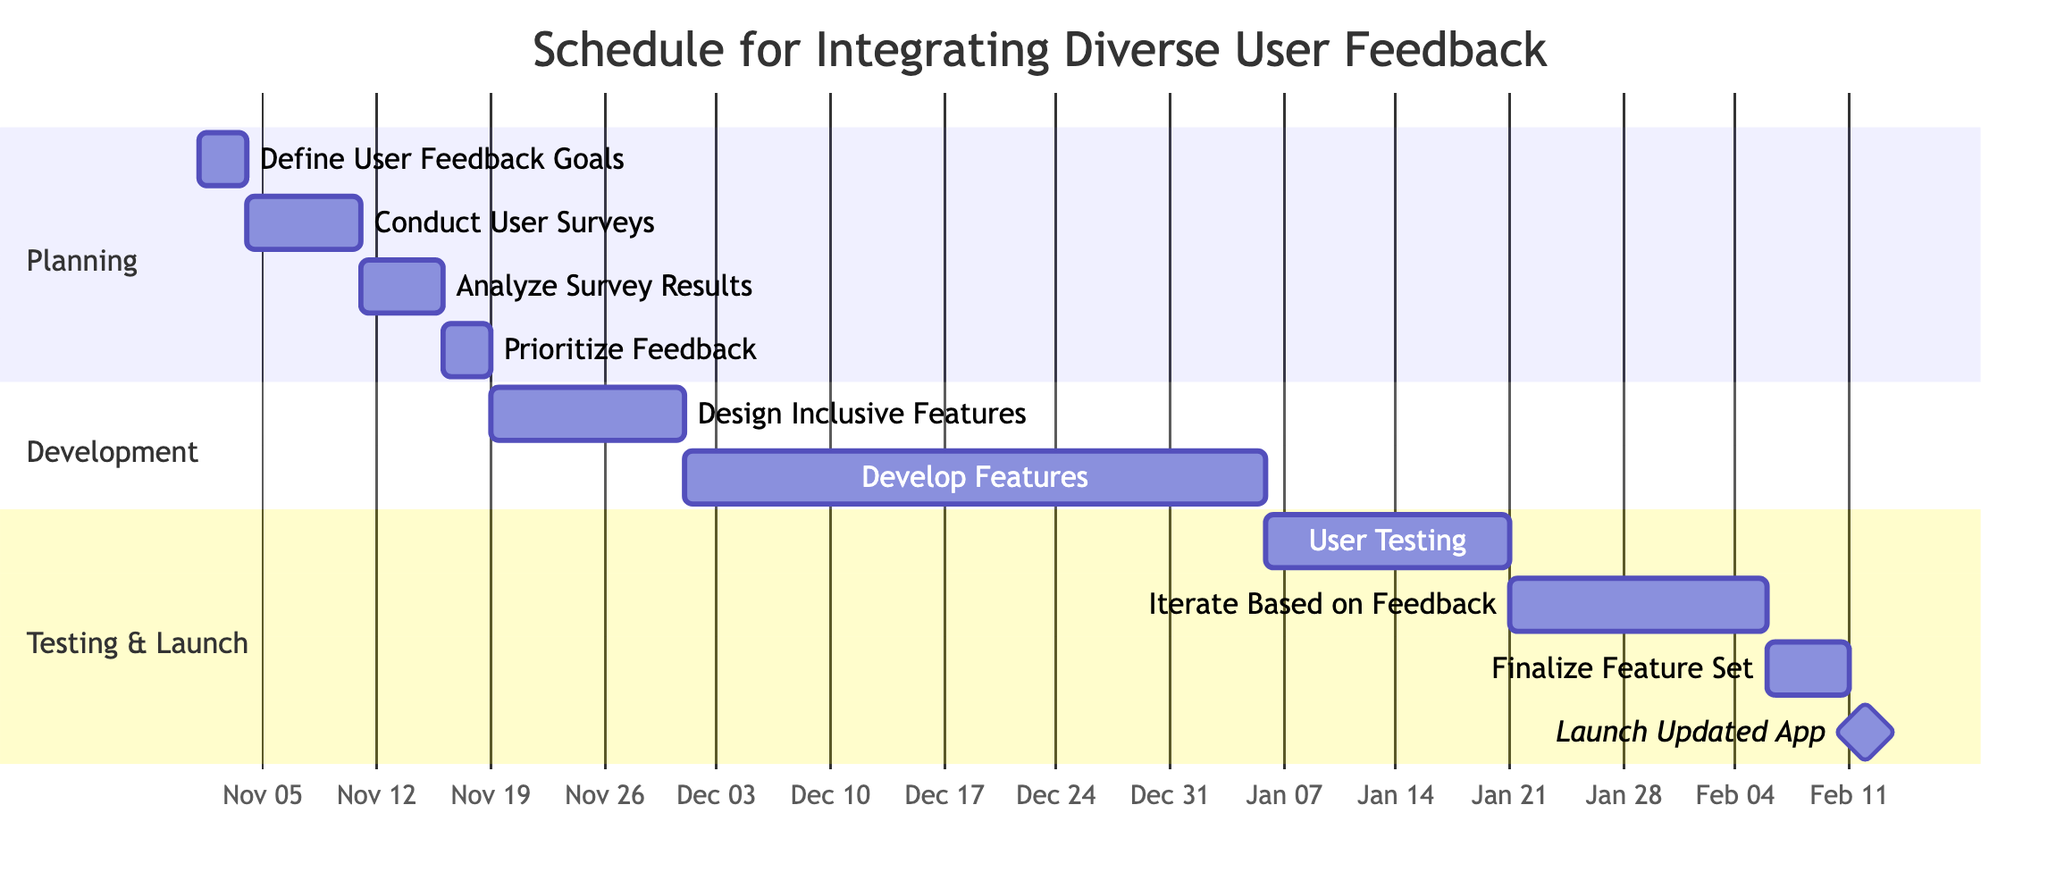what is the duration of the task 'Conduct User Surveys'? The task 'Conduct User Surveys' lasts from November 4 to November 10, which is a total duration of 7 days as indicated in the diagram.
Answer: 7 days when does the task 'Design Inclusive Features' start? The task 'Design Inclusive Features' begins after 'Prioritize Feedback', which ends on November 18. It therefore starts on November 19.
Answer: November 19 how many days are allocated for 'User Testing'? The task 'User Testing' runs from January 6 to January 20, which is a duration of 15 days as shown in the chart.
Answer: 15 days which task follows 'Develop Features'? The task that follows 'Develop Features' is 'User Testing', which starts right after it is completed. This indicates that user testing will begin right after development is concluded.
Answer: User Testing what is the total duration from 'Define User Feedback Goals' to 'Launch Updated App'? To find the total duration, we start from 'Define User Feedback Goals' on November 1 and end at 'Launch Updated App' on February 12. This totals 73 days when counted from start to end across all the dependent tasks.
Answer: 73 days what are the names of all tasks in the 'Development' section? The tasks in the 'Development' section are 'Design Inclusive Features' and 'Develop Features', as these are clearly delineated under this section of the Gantt chart.
Answer: Design Inclusive Features, Develop Features which task is a milestone and when does it occur? The task 'Launch Updated App' is marked as a milestone and it occurs after the 'Finalize Feature Set', specifically from February 11 to February 12.
Answer: Launch Updated App, February 11 what is the end date for the task 'Prioritize Feedback'? The task 'Prioritize Feedback' ends on November 18, immediately marking the conclusion of its duration.
Answer: November 18 